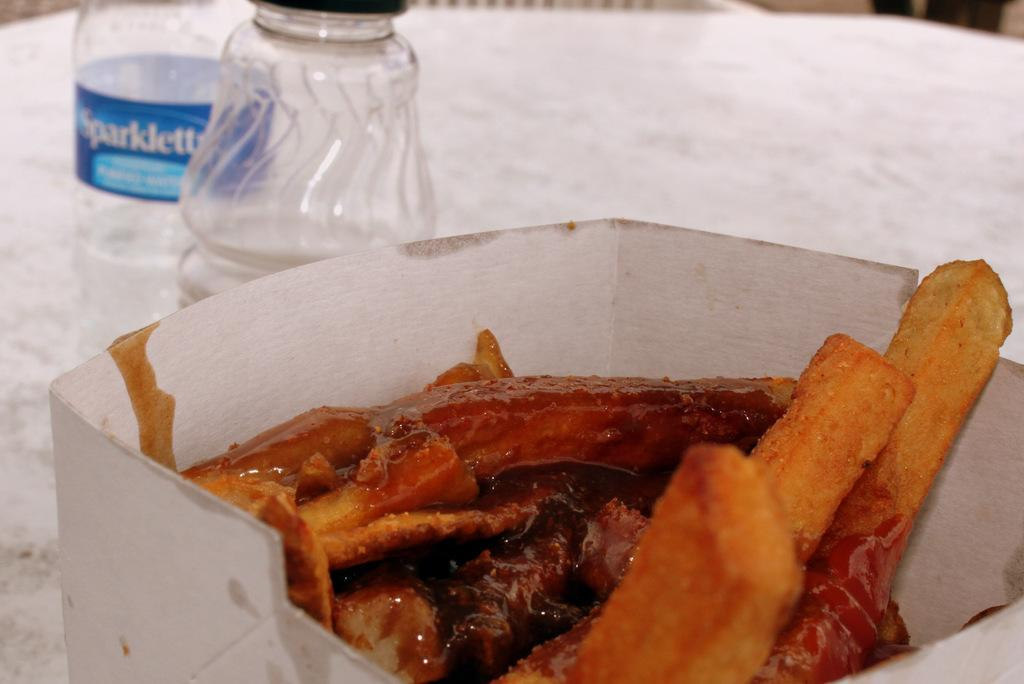Provide a one-sentence caption for the provided image. A container of bacon along with 2 bottles one of which is Sparklette drinking water. 